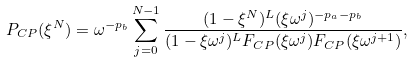<formula> <loc_0><loc_0><loc_500><loc_500>& P _ { C P } ( \xi ^ { N } ) = \omega ^ { - p _ { b } } \sum _ { j = 0 } ^ { N - 1 } \frac { ( 1 - \xi ^ { N } ) ^ { L } ( \xi \omega ^ { j } ) ^ { - p _ { a } - p _ { b } } } { ( 1 - \xi \omega ^ { j } ) ^ { L } F _ { C P } ( \xi \omega ^ { j } ) F _ { C P } ( \xi \omega ^ { j + 1 } ) } ,</formula> 